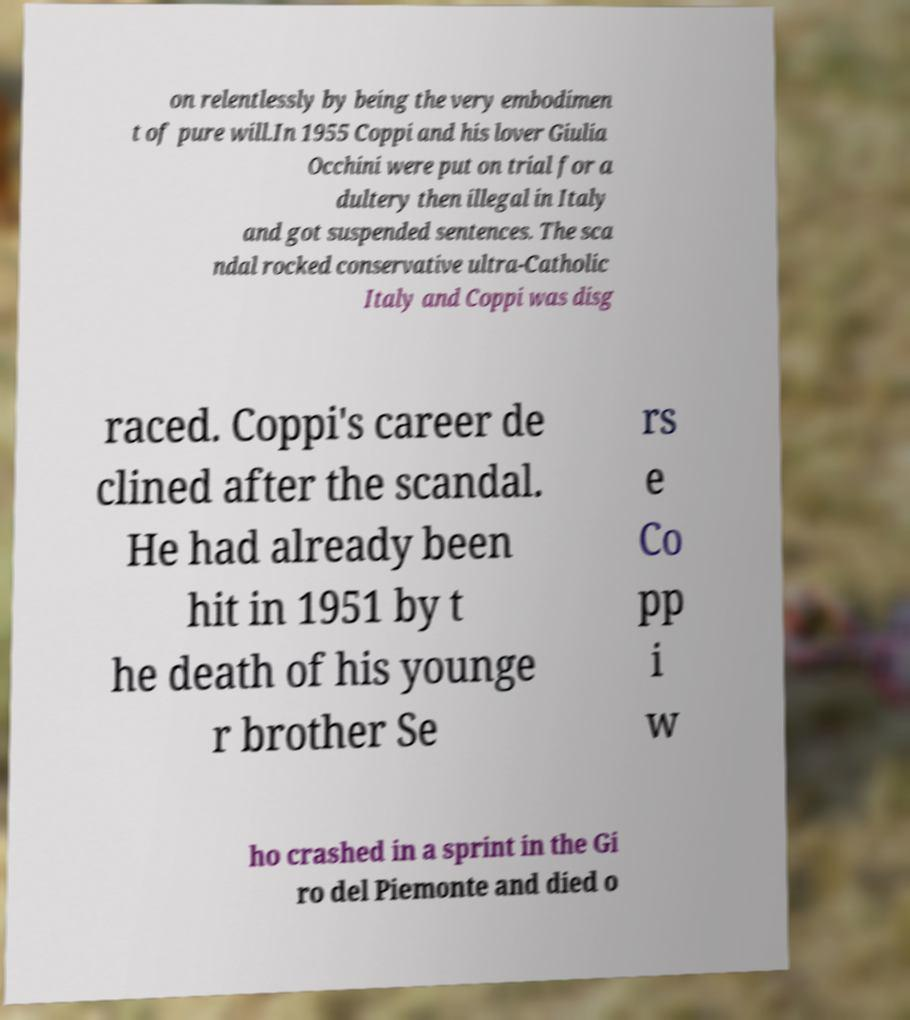For documentation purposes, I need the text within this image transcribed. Could you provide that? on relentlessly by being the very embodimen t of pure will.In 1955 Coppi and his lover Giulia Occhini were put on trial for a dultery then illegal in Italy and got suspended sentences. The sca ndal rocked conservative ultra-Catholic Italy and Coppi was disg raced. Coppi's career de clined after the scandal. He had already been hit in 1951 by t he death of his younge r brother Se rs e Co pp i w ho crashed in a sprint in the Gi ro del Piemonte and died o 